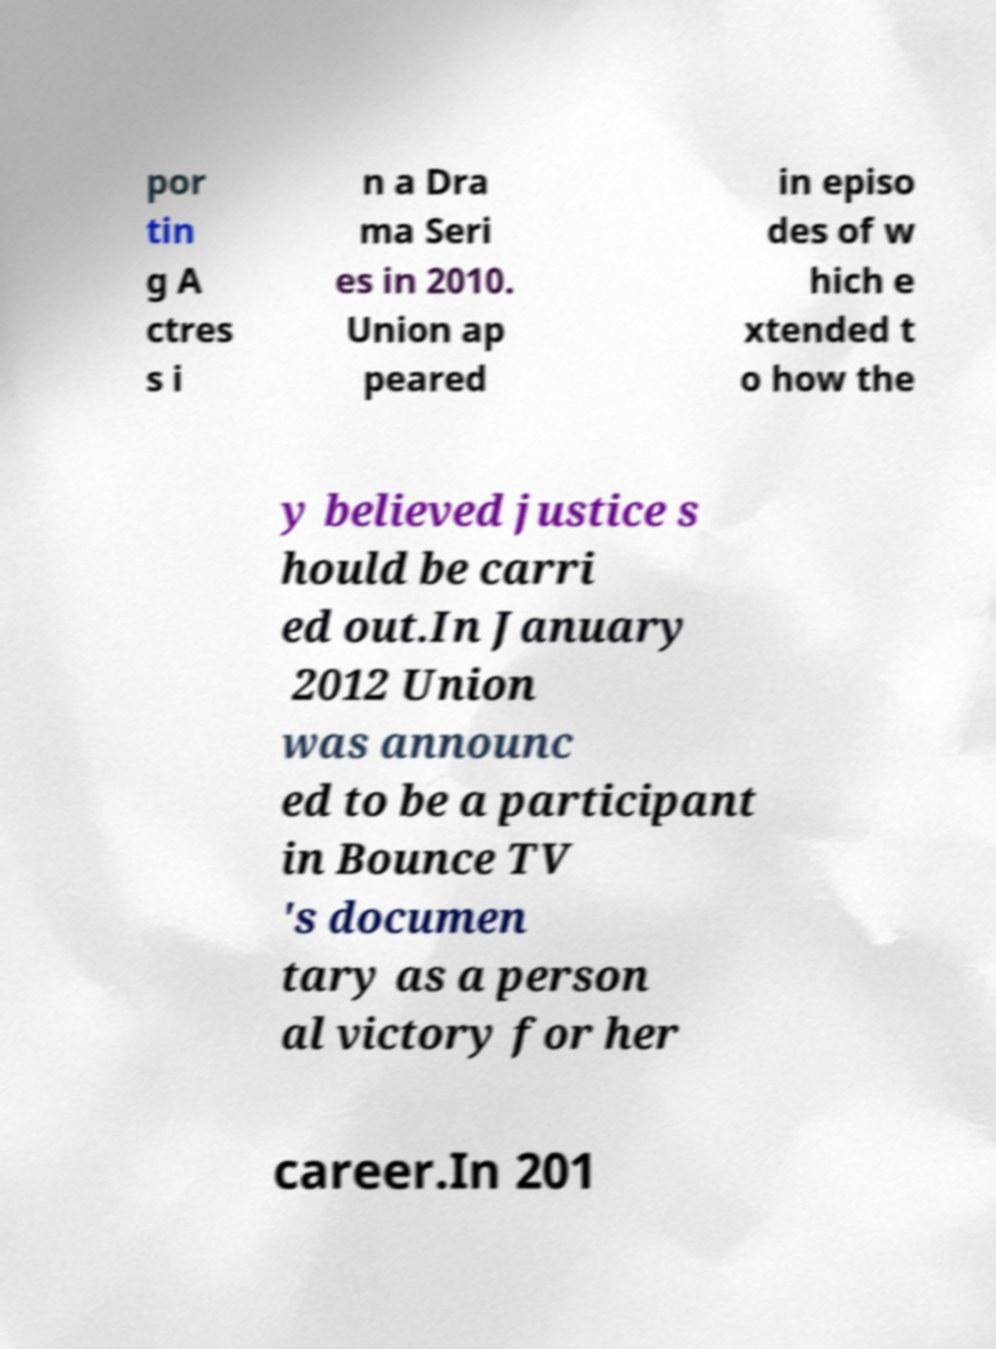Can you accurately transcribe the text from the provided image for me? por tin g A ctres s i n a Dra ma Seri es in 2010. Union ap peared in episo des of w hich e xtended t o how the y believed justice s hould be carri ed out.In January 2012 Union was announc ed to be a participant in Bounce TV 's documen tary as a person al victory for her career.In 201 